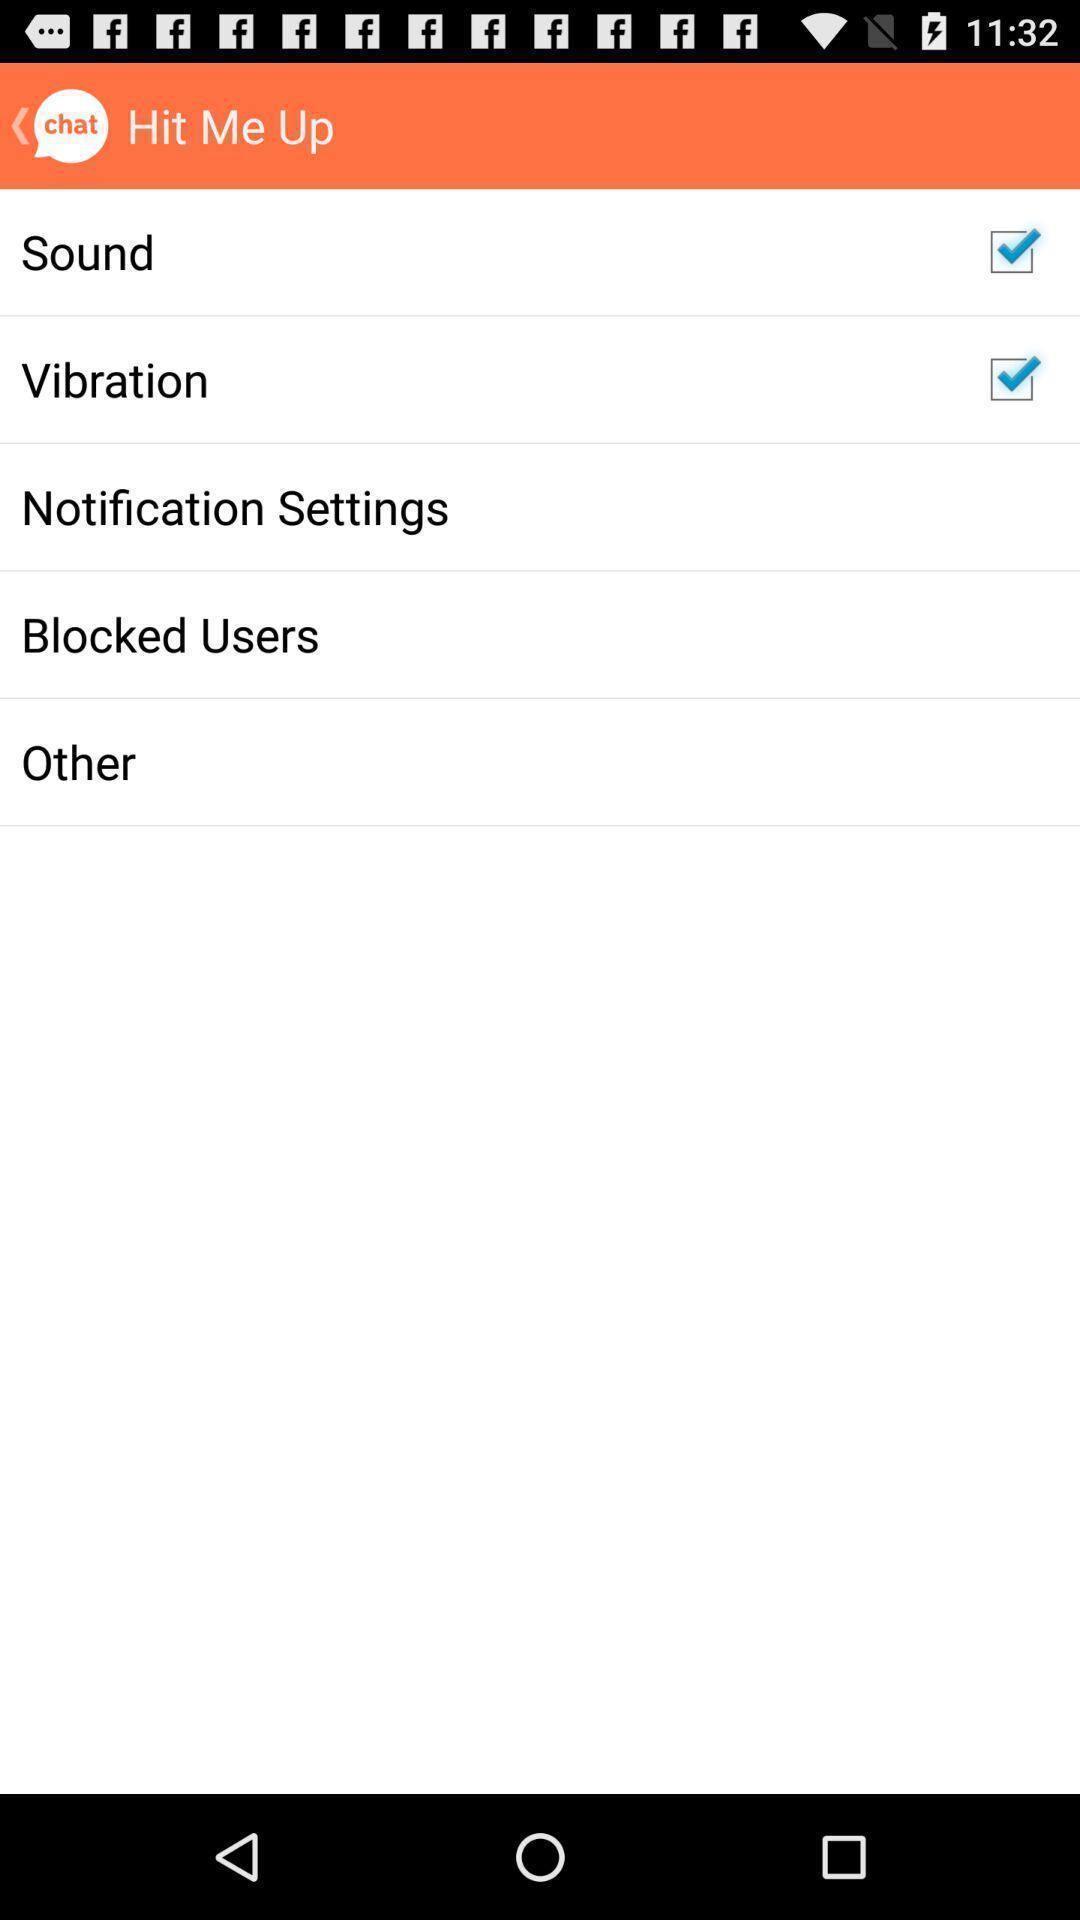Please provide a description for this image. Showing various options of a social app. 